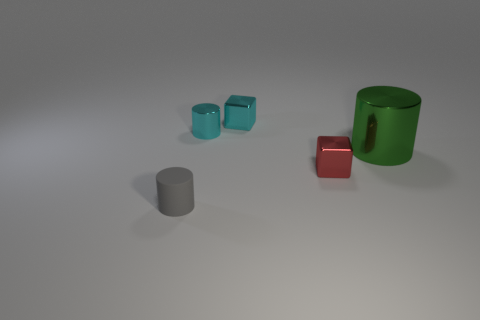What is the color of the tiny cylinder that is the same material as the large cylinder?
Offer a terse response. Cyan. How many cubes are either tiny blue things or red metal things?
Keep it short and to the point. 1. How many things are either cyan objects or small cylinders that are in front of the small red block?
Your answer should be very brief. 3. Are there any red cubes?
Make the answer very short. Yes. What number of other matte cylinders are the same color as the large cylinder?
Your response must be concise. 0. There is a block that is the same color as the tiny shiny cylinder; what is its material?
Give a very brief answer. Metal. How big is the green thing that is to the right of the tiny cylinder that is to the right of the small rubber object?
Offer a terse response. Large. Are there any yellow blocks made of the same material as the gray object?
Give a very brief answer. No. What is the material of the cyan cylinder that is the same size as the gray cylinder?
Provide a succinct answer. Metal. Do the small shiny cube that is on the right side of the cyan cube and the tiny cylinder that is behind the large cylinder have the same color?
Offer a very short reply. No. 